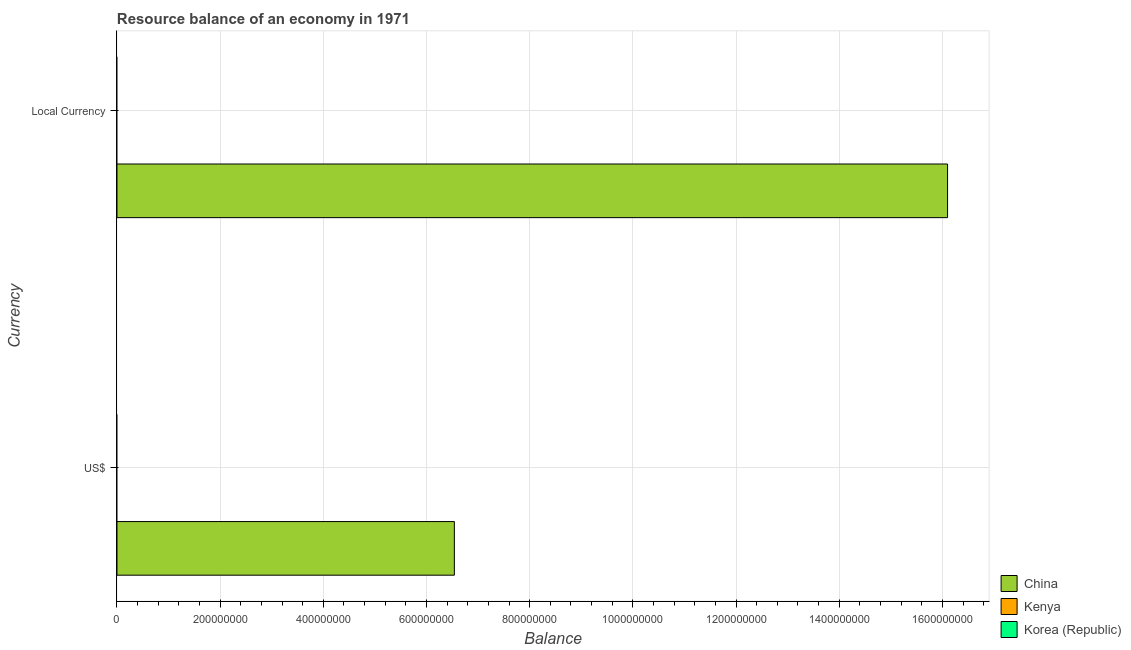How many different coloured bars are there?
Give a very brief answer. 1. How many bars are there on the 2nd tick from the top?
Your response must be concise. 1. What is the label of the 1st group of bars from the top?
Provide a short and direct response. Local Currency. Across all countries, what is the maximum resource balance in constant us$?
Your answer should be very brief. 1.61e+09. Across all countries, what is the minimum resource balance in constant us$?
Your answer should be very brief. 0. In which country was the resource balance in us$ maximum?
Give a very brief answer. China. What is the total resource balance in constant us$ in the graph?
Make the answer very short. 1.61e+09. What is the difference between the resource balance in constant us$ in China and the resource balance in us$ in Kenya?
Provide a succinct answer. 1.61e+09. What is the average resource balance in constant us$ per country?
Provide a short and direct response. 5.37e+08. What is the difference between the resource balance in constant us$ and resource balance in us$ in China?
Make the answer very short. 9.56e+08. In how many countries, is the resource balance in us$ greater than 720000000 units?
Give a very brief answer. 0. In how many countries, is the resource balance in us$ greater than the average resource balance in us$ taken over all countries?
Give a very brief answer. 1. How many countries are there in the graph?
Offer a very short reply. 3. What is the difference between two consecutive major ticks on the X-axis?
Keep it short and to the point. 2.00e+08. Does the graph contain any zero values?
Your response must be concise. Yes. Does the graph contain grids?
Offer a very short reply. Yes. Where does the legend appear in the graph?
Ensure brevity in your answer.  Bottom right. How are the legend labels stacked?
Give a very brief answer. Vertical. What is the title of the graph?
Your answer should be very brief. Resource balance of an economy in 1971. Does "Latin America(developing only)" appear as one of the legend labels in the graph?
Offer a terse response. No. What is the label or title of the X-axis?
Provide a succinct answer. Balance. What is the label or title of the Y-axis?
Your answer should be compact. Currency. What is the Balance in China in US$?
Give a very brief answer. 6.54e+08. What is the Balance of Kenya in US$?
Ensure brevity in your answer.  0. What is the Balance of China in Local Currency?
Offer a very short reply. 1.61e+09. Across all Currency, what is the maximum Balance in China?
Offer a very short reply. 1.61e+09. Across all Currency, what is the minimum Balance in China?
Make the answer very short. 6.54e+08. What is the total Balance in China in the graph?
Offer a very short reply. 2.26e+09. What is the total Balance of Kenya in the graph?
Your answer should be very brief. 0. What is the total Balance in Korea (Republic) in the graph?
Ensure brevity in your answer.  0. What is the difference between the Balance in China in US$ and that in Local Currency?
Your answer should be compact. -9.56e+08. What is the average Balance in China per Currency?
Keep it short and to the point. 1.13e+09. What is the average Balance of Kenya per Currency?
Your response must be concise. 0. What is the average Balance of Korea (Republic) per Currency?
Provide a short and direct response. 0. What is the ratio of the Balance in China in US$ to that in Local Currency?
Provide a short and direct response. 0.41. What is the difference between the highest and the second highest Balance of China?
Offer a terse response. 9.56e+08. What is the difference between the highest and the lowest Balance in China?
Ensure brevity in your answer.  9.56e+08. 